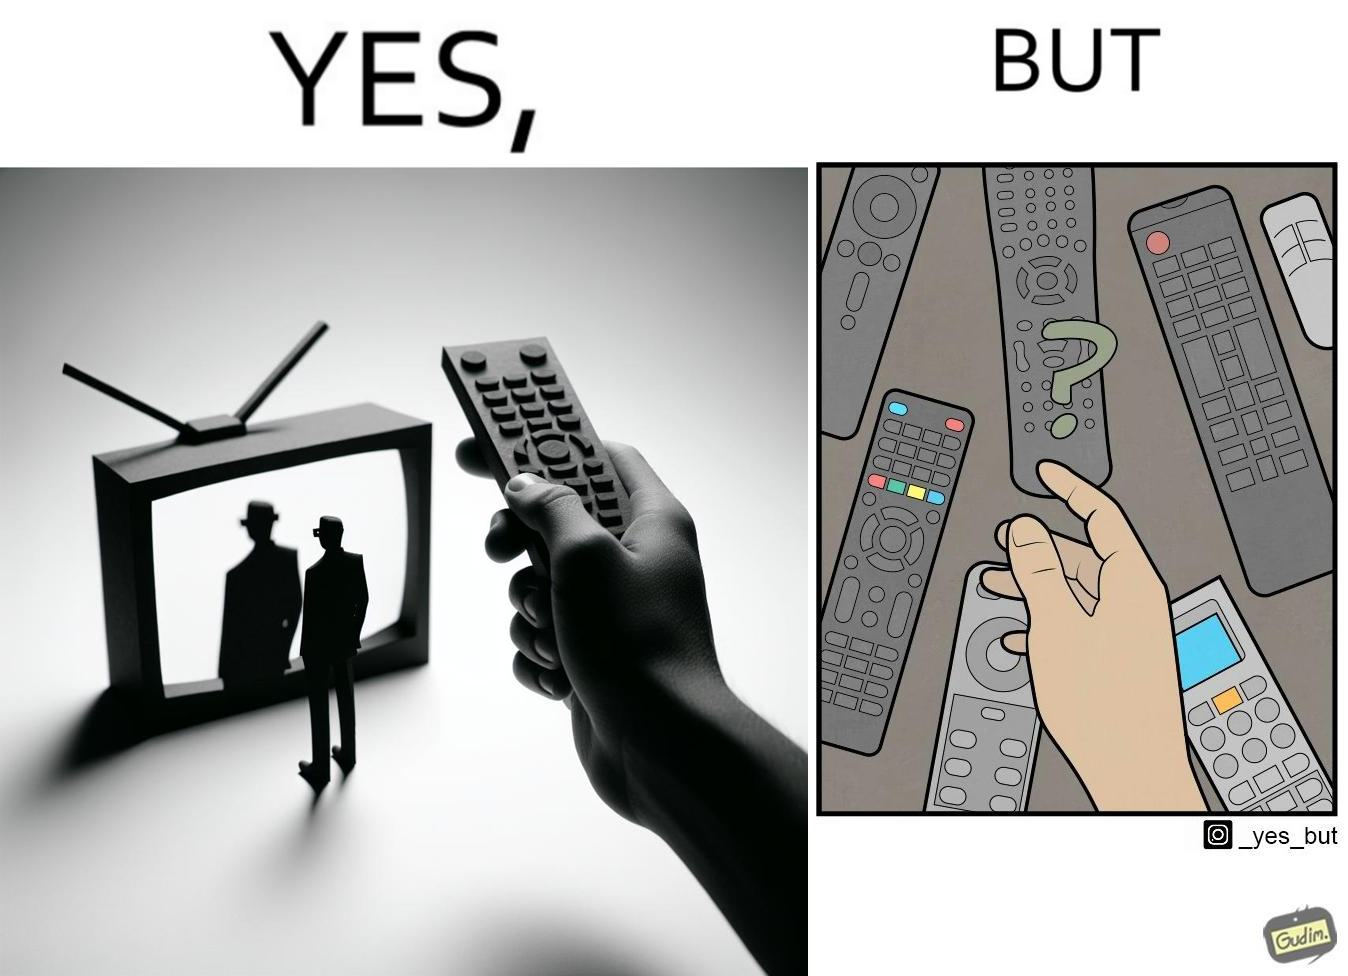Describe the satirical element in this image. The images are funny since they show how even though TV remotes are supposed to make operating TVs easier, having multiple similar looking remotes  for everything only makes it more difficult for the user to use the right one 